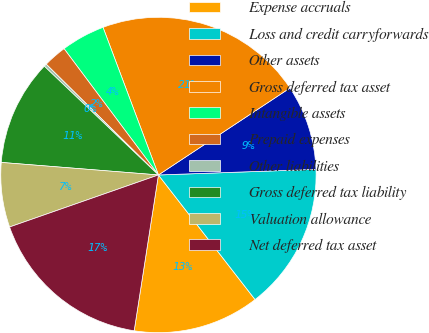Convert chart. <chart><loc_0><loc_0><loc_500><loc_500><pie_chart><fcel>Expense accruals<fcel>Loss and credit carryforwards<fcel>Other assets<fcel>Gross deferred tax asset<fcel>Intangible assets<fcel>Prepaid expenses<fcel>Other liabilities<fcel>Gross deferred tax liability<fcel>Valuation allowance<fcel>Net deferred tax asset<nl><fcel>12.96%<fcel>15.07%<fcel>8.73%<fcel>21.42%<fcel>4.5%<fcel>2.39%<fcel>0.28%<fcel>10.85%<fcel>6.62%<fcel>17.19%<nl></chart> 